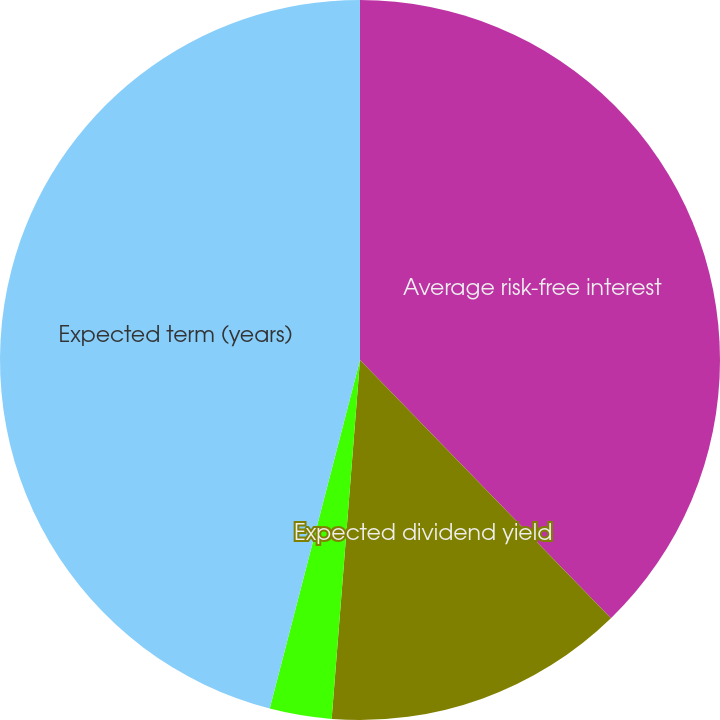Convert chart. <chart><loc_0><loc_0><loc_500><loc_500><pie_chart><fcel>Average risk-free interest<fcel>Expected dividend yield<fcel>Expected volatility<fcel>Expected term (years)<nl><fcel>37.73%<fcel>13.53%<fcel>2.78%<fcel>45.97%<nl></chart> 